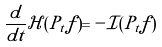<formula> <loc_0><loc_0><loc_500><loc_500>\frac { d } { d t } \mathcal { H } ( P _ { t } f ) = - \mathcal { I } ( P _ { t } f )</formula> 